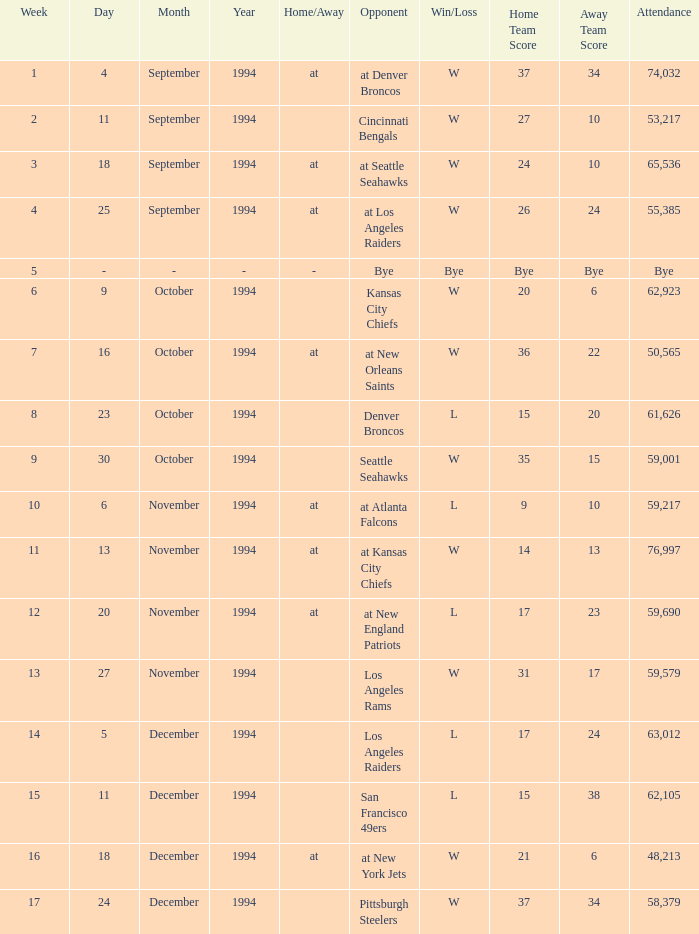On November 20, 1994, what was the result of the game? L 17–23. 